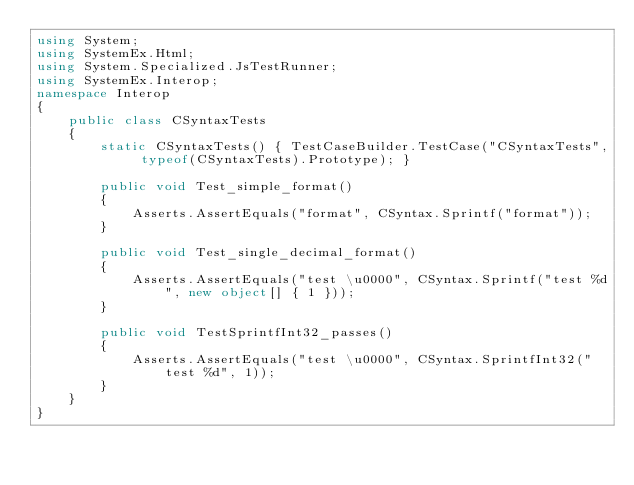<code> <loc_0><loc_0><loc_500><loc_500><_C#_>using System;
using SystemEx.Html;
using System.Specialized.JsTestRunner;
using SystemEx.Interop;
namespace Interop
{
    public class CSyntaxTests
    {
        static CSyntaxTests() { TestCaseBuilder.TestCase("CSyntaxTests", typeof(CSyntaxTests).Prototype); }

        public void Test_simple_format()
        {
            Asserts.AssertEquals("format", CSyntax.Sprintf("format"));
        }

        public void Test_single_decimal_format()
        {
            Asserts.AssertEquals("test \u0000", CSyntax.Sprintf("test %d", new object[] { 1 }));
        }

        public void TestSprintfInt32_passes()
        {
            Asserts.AssertEquals("test \u0000", CSyntax.SprintfInt32("test %d", 1));
        }
    }
}</code> 